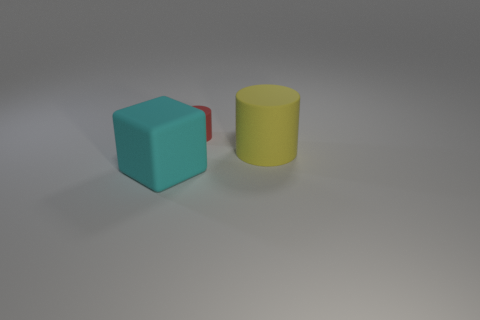Does the tiny red thing have the same shape as the big cyan thing?
Offer a very short reply. No. How many other objects are the same shape as the cyan thing?
Give a very brief answer. 0. There is a rubber object that is in front of the big yellow matte cylinder; does it have the same color as the matte cylinder that is in front of the small red object?
Give a very brief answer. No. How many tiny things are green matte objects or cyan matte cubes?
Keep it short and to the point. 0. What is the size of the other rubber object that is the same shape as the red rubber object?
Keep it short and to the point. Large. Is there anything else that is the same size as the yellow cylinder?
Provide a short and direct response. Yes. What is the material of the thing in front of the big rubber object behind the big cyan object?
Your response must be concise. Rubber. How many rubber objects are either big cubes or large yellow spheres?
Your response must be concise. 1. What is the color of the other thing that is the same shape as the tiny object?
Your answer should be compact. Yellow. Are there any cyan rubber objects to the right of the big matte thing right of the rubber cube?
Ensure brevity in your answer.  No. 